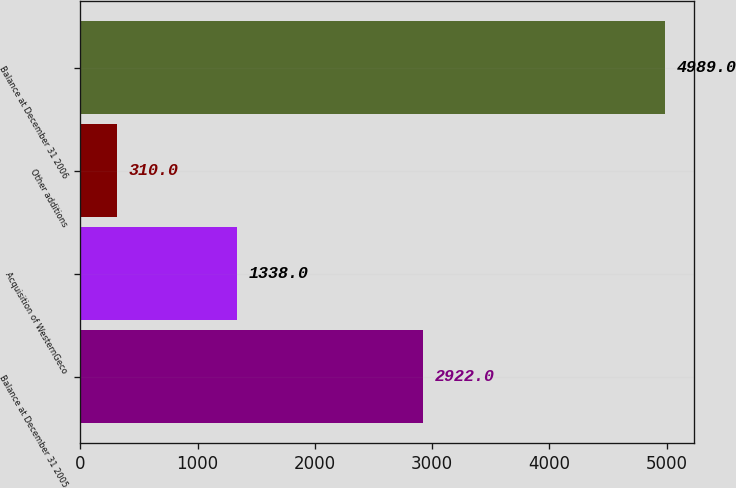Convert chart to OTSL. <chart><loc_0><loc_0><loc_500><loc_500><bar_chart><fcel>Balance at December 31 2005<fcel>Acquisition of WesternGeco<fcel>Other additions<fcel>Balance at December 31 2006<nl><fcel>2922<fcel>1338<fcel>310<fcel>4989<nl></chart> 